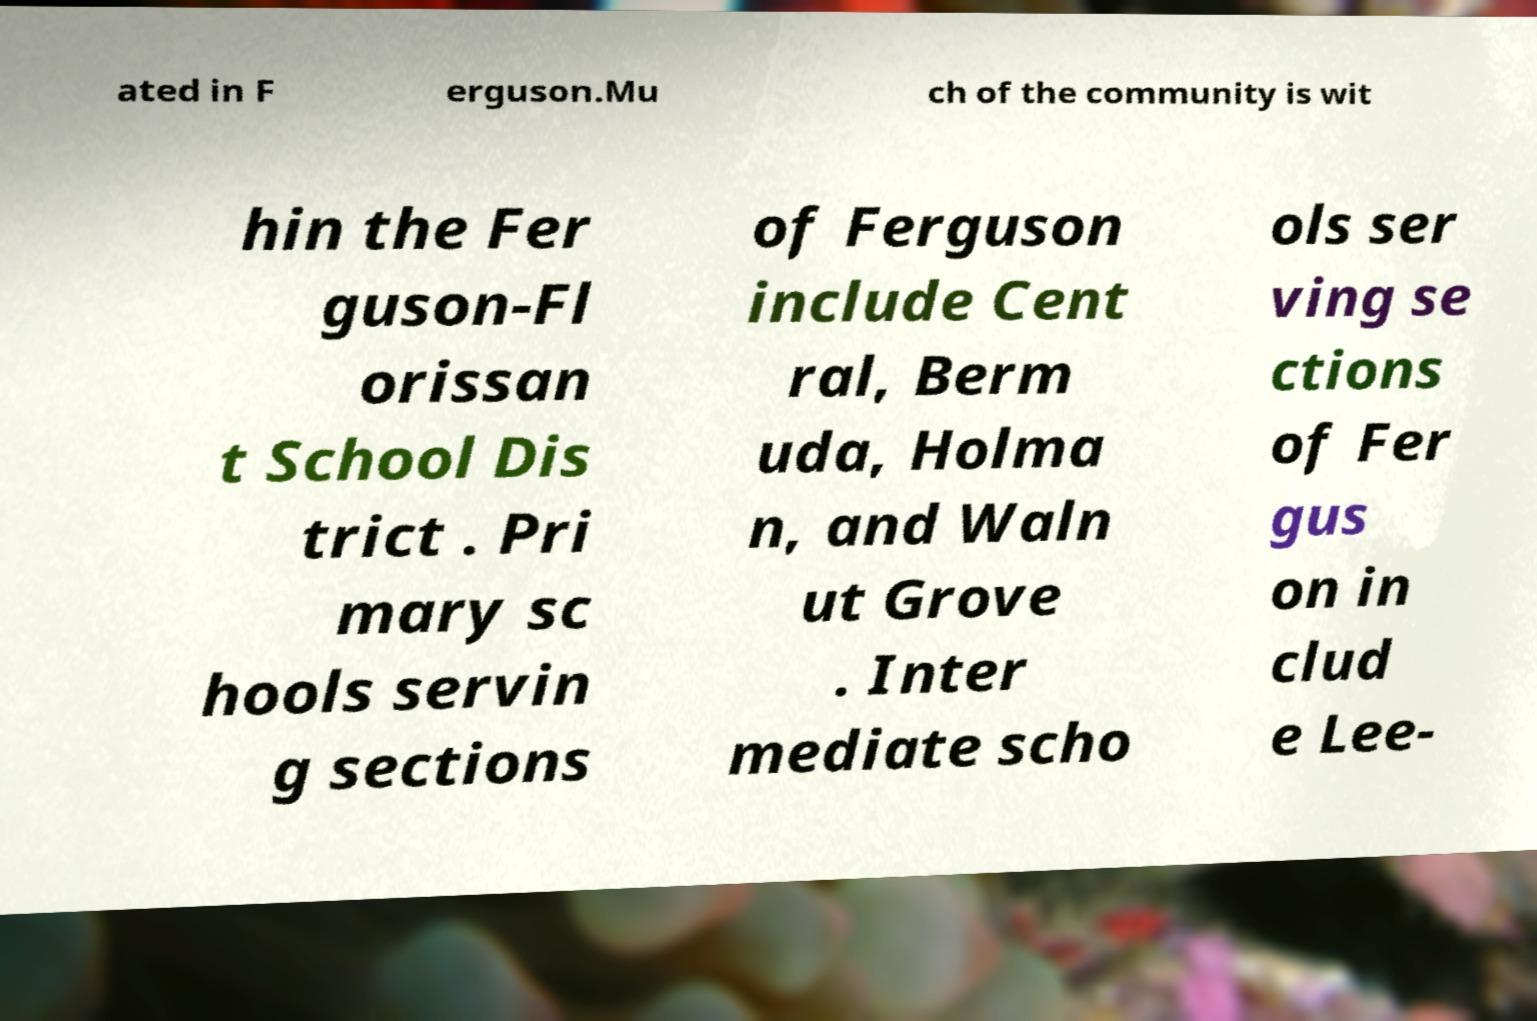What messages or text are displayed in this image? I need them in a readable, typed format. ated in F erguson.Mu ch of the community is wit hin the Fer guson-Fl orissan t School Dis trict . Pri mary sc hools servin g sections of Ferguson include Cent ral, Berm uda, Holma n, and Waln ut Grove . Inter mediate scho ols ser ving se ctions of Fer gus on in clud e Lee- 